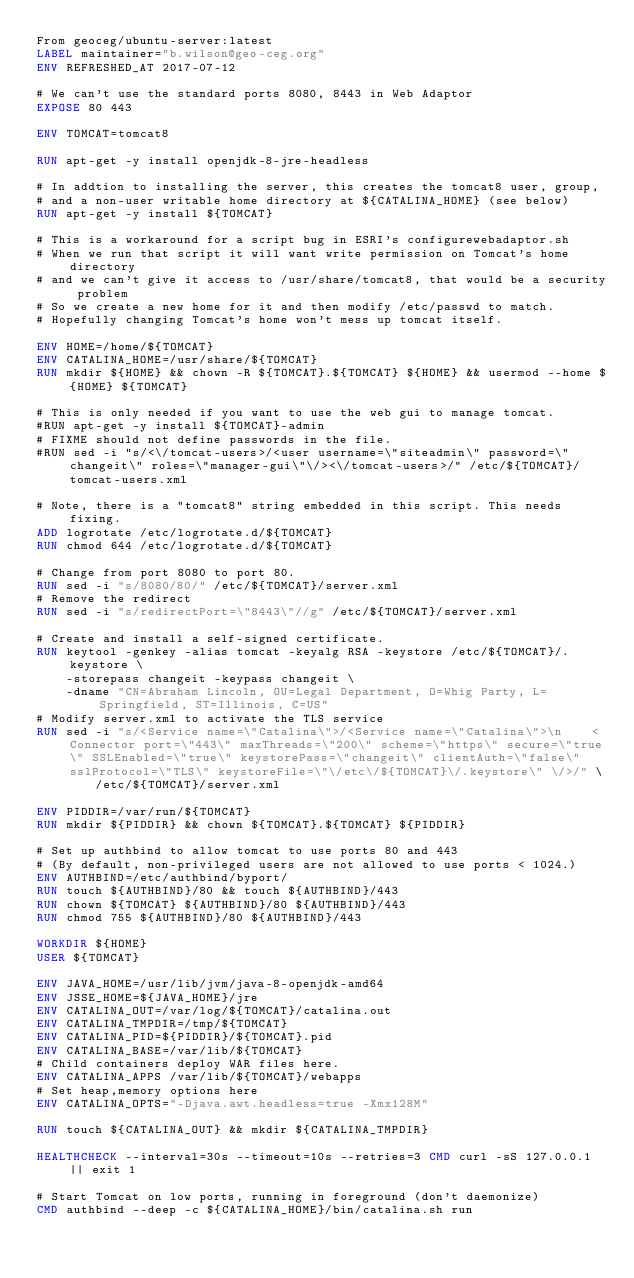Convert code to text. <code><loc_0><loc_0><loc_500><loc_500><_Dockerfile_>From geoceg/ubuntu-server:latest
LABEL maintainer="b.wilson@geo-ceg.org"
ENV REFRESHED_AT 2017-07-12

# We can't use the standard ports 8080, 8443 in Web Adaptor
EXPOSE 80 443

ENV TOMCAT=tomcat8

RUN apt-get -y install openjdk-8-jre-headless

# In addtion to installing the server, this creates the tomcat8 user, group,
# and a non-user writable home directory at ${CATALINA_HOME} (see below)
RUN apt-get -y install ${TOMCAT}

# This is a workaround for a script bug in ESRI's configurewebadaptor.sh
# When we run that script it will want write permission on Tomcat's home directory
# and we can't give it access to /usr/share/tomcat8, that would be a security problem
# So we create a new home for it and then modify /etc/passwd to match.
# Hopefully changing Tomcat's home won't mess up tomcat itself.

ENV HOME=/home/${TOMCAT}
ENV CATALINA_HOME=/usr/share/${TOMCAT}
RUN mkdir ${HOME} && chown -R ${TOMCAT}.${TOMCAT} ${HOME} && usermod --home ${HOME} ${TOMCAT}

# This is only needed if you want to use the web gui to manage tomcat.
#RUN apt-get -y install ${TOMCAT}-admin
# FIXME should not define passwords in the file.
#RUN sed -i "s/<\/tomcat-users>/<user username=\"siteadmin\" password=\"changeit\" roles=\"manager-gui\"\/><\/tomcat-users>/" /etc/${TOMCAT}/tomcat-users.xml

# Note, there is a "tomcat8" string embedded in this script. This needs fixing.
ADD logrotate /etc/logrotate.d/${TOMCAT}
RUN chmod 644 /etc/logrotate.d/${TOMCAT}

# Change from port 8080 to port 80.
RUN sed -i "s/8080/80/" /etc/${TOMCAT}/server.xml
# Remove the redirect
RUN sed -i "s/redirectPort=\"8443\"//g" /etc/${TOMCAT}/server.xml

# Create and install a self-signed certificate.
RUN keytool -genkey -alias tomcat -keyalg RSA -keystore /etc/${TOMCAT}/.keystore \
    -storepass changeit -keypass changeit \
    -dname "CN=Abraham Lincoln, OU=Legal Department, O=Whig Party, L=Springfield, ST=Illinois, C=US"
# Modify server.xml to activate the TLS service
RUN sed -i "s/<Service name=\"Catalina\">/<Service name=\"Catalina\">\n    <Connector port=\"443\" maxThreads=\"200\" scheme=\"https\" secure=\"true\" SSLEnabled=\"true\" keystorePass=\"changeit\" clientAuth=\"false\" sslProtocol=\"TLS\" keystoreFile=\"\/etc\/${TOMCAT}\/.keystore\" \/>/" \
        /etc/${TOMCAT}/server.xml

ENV PIDDIR=/var/run/${TOMCAT}
RUN mkdir ${PIDDIR} && chown ${TOMCAT}.${TOMCAT} ${PIDDIR}

# Set up authbind to allow tomcat to use ports 80 and 443
# (By default, non-privileged users are not allowed to use ports < 1024.)
ENV AUTHBIND=/etc/authbind/byport/
RUN touch ${AUTHBIND}/80 && touch ${AUTHBIND}/443
RUN chown ${TOMCAT} ${AUTHBIND}/80 ${AUTHBIND}/443
RUN chmod 755 ${AUTHBIND}/80 ${AUTHBIND}/443

WORKDIR ${HOME}
USER ${TOMCAT}

ENV JAVA_HOME=/usr/lib/jvm/java-8-openjdk-amd64
ENV JSSE_HOME=${JAVA_HOME}/jre
ENV CATALINA_OUT=/var/log/${TOMCAT}/catalina.out
ENV CATALINA_TMPDIR=/tmp/${TOMCAT}
ENV CATALINA_PID=${PIDDIR}/${TOMCAT}.pid
ENV CATALINA_BASE=/var/lib/${TOMCAT}
# Child containers deploy WAR files here.
ENV CATALINA_APPS /var/lib/${TOMCAT}/webapps
# Set heap,memory options here
ENV CATALINA_OPTS="-Djava.awt.headless=true -Xmx128M"

RUN touch ${CATALINA_OUT} && mkdir ${CATALINA_TMPDIR}

HEALTHCHECK --interval=30s --timeout=10s --retries=3 CMD curl -sS 127.0.0.1 || exit 1

# Start Tomcat on low ports, running in foreground (don't daemonize)
CMD authbind --deep -c ${CATALINA_HOME}/bin/catalina.sh run

</code> 